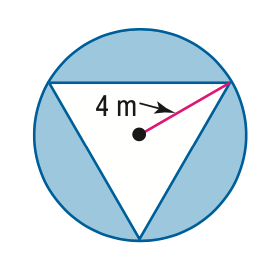Answer the mathemtical geometry problem and directly provide the correct option letter.
Question: Find the area of the shaded region. Assume that the triangle is equilateral.
Choices: A: 20.8 B: 29.5 C: 50.3 D: 71.1 B 